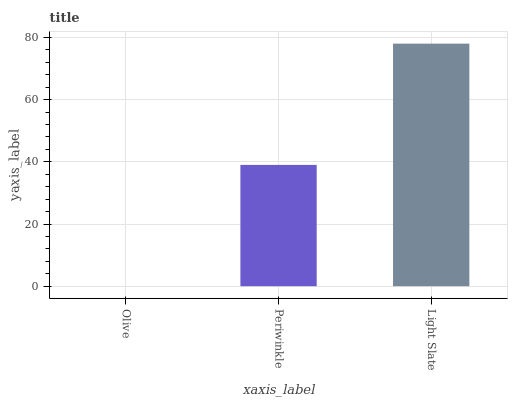Is Olive the minimum?
Answer yes or no. Yes. Is Light Slate the maximum?
Answer yes or no. Yes. Is Periwinkle the minimum?
Answer yes or no. No. Is Periwinkle the maximum?
Answer yes or no. No. Is Periwinkle greater than Olive?
Answer yes or no. Yes. Is Olive less than Periwinkle?
Answer yes or no. Yes. Is Olive greater than Periwinkle?
Answer yes or no. No. Is Periwinkle less than Olive?
Answer yes or no. No. Is Periwinkle the high median?
Answer yes or no. Yes. Is Periwinkle the low median?
Answer yes or no. Yes. Is Olive the high median?
Answer yes or no. No. Is Olive the low median?
Answer yes or no. No. 